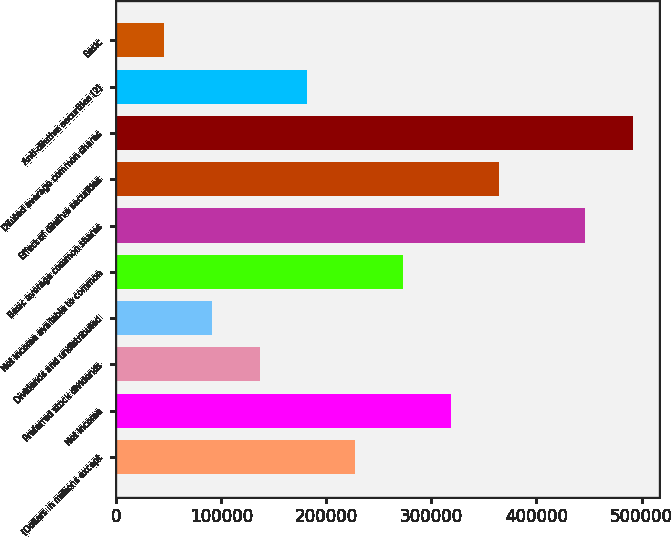Convert chart to OTSL. <chart><loc_0><loc_0><loc_500><loc_500><bar_chart><fcel>(Dollars in millions except<fcel>Net income<fcel>Preferred stock dividends<fcel>Dividends and undistributed<fcel>Net income available to common<fcel>Basic average common shares<fcel>Effect of dilutive securities<fcel>Diluted average common shares<fcel>Anti-dilutive securities (2)<fcel>Basic<nl><fcel>227580<fcel>318610<fcel>136550<fcel>91034.7<fcel>273095<fcel>446245<fcel>364125<fcel>491760<fcel>182065<fcel>45519.7<nl></chart> 